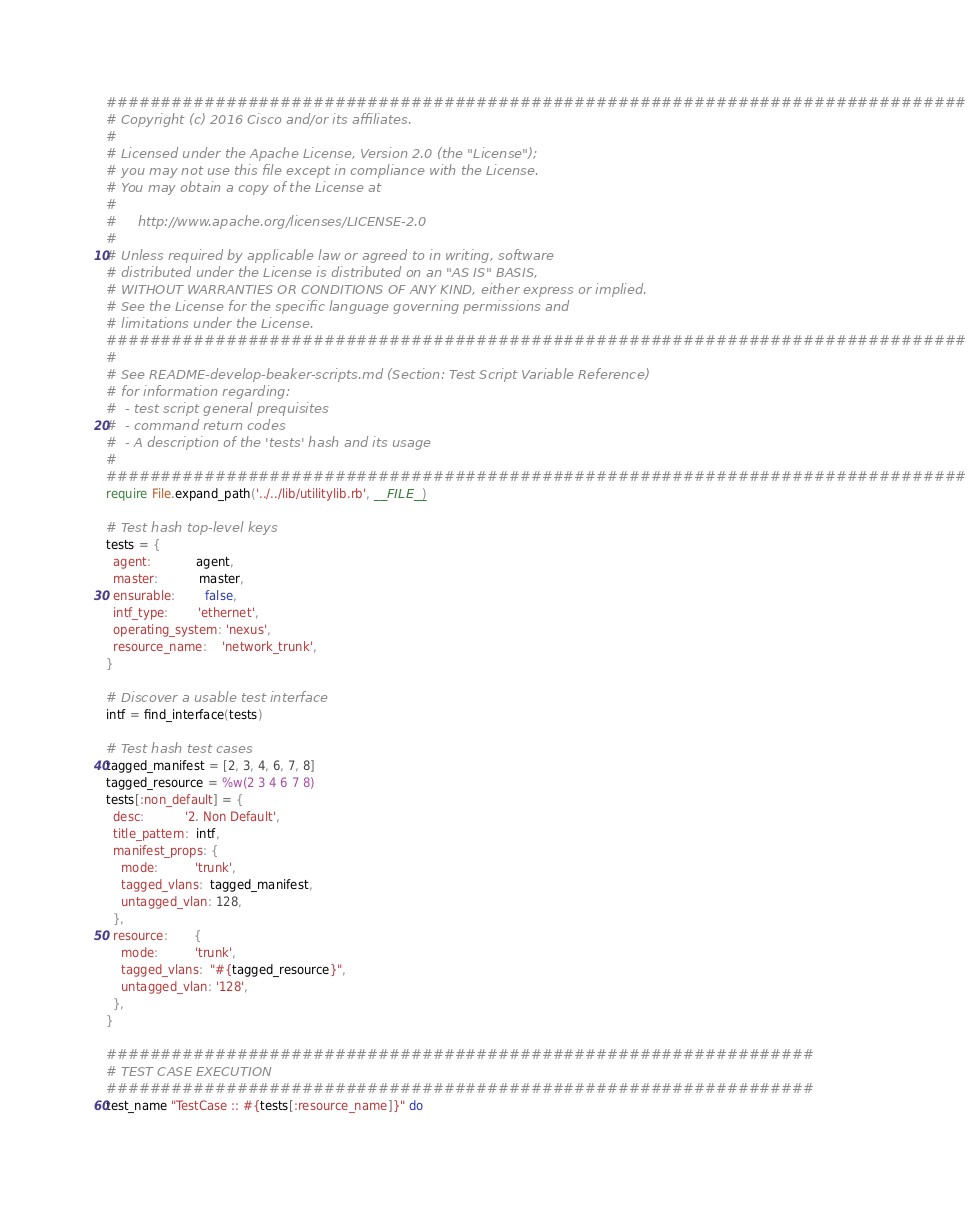<code> <loc_0><loc_0><loc_500><loc_500><_Ruby_>###############################################################################
# Copyright (c) 2016 Cisco and/or its affiliates.
#
# Licensed under the Apache License, Version 2.0 (the "License");
# you may not use this file except in compliance with the License.
# You may obtain a copy of the License at
#
#     http://www.apache.org/licenses/LICENSE-2.0
#
# Unless required by applicable law or agreed to in writing, software
# distributed under the License is distributed on an "AS IS" BASIS,
# WITHOUT WARRANTIES OR CONDITIONS OF ANY KIND, either express or implied.
# See the License for the specific language governing permissions and
# limitations under the License.
###############################################################################
#
# See README-develop-beaker-scripts.md (Section: Test Script Variable Reference)
# for information regarding:
#  - test script general prequisites
#  - command return codes
#  - A description of the 'tests' hash and its usage
#
###############################################################################
require File.expand_path('../../lib/utilitylib.rb', __FILE__)

# Test hash top-level keys
tests = {
  agent:            agent,
  master:           master,
  ensurable:        false,
  intf_type:        'ethernet',
  operating_system: 'nexus',
  resource_name:    'network_trunk',
}

# Discover a usable test interface
intf = find_interface(tests)

# Test hash test cases
tagged_manifest = [2, 3, 4, 6, 7, 8]
tagged_resource = %w(2 3 4 6 7 8)
tests[:non_default] = {
  desc:           '2. Non Default',
  title_pattern:  intf,
  manifest_props: {
    mode:          'trunk',
    tagged_vlans:  tagged_manifest,
    untagged_vlan: 128,
  },
  resource:       {
    mode:          'trunk',
    tagged_vlans:  "#{tagged_resource}",
    untagged_vlan: '128',
  },
}

#################################################################
# TEST CASE EXECUTION
#################################################################
test_name "TestCase :: #{tests[:resource_name]}" do</code> 